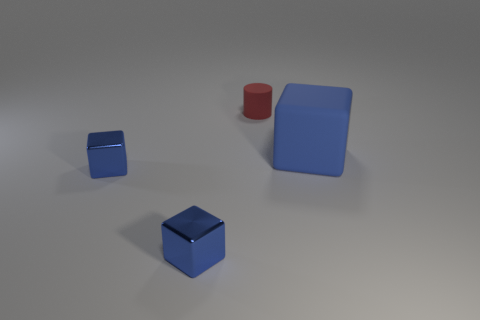Add 1 big cubes. How many objects exist? 5 Subtract all cylinders. How many objects are left? 3 Add 3 blue shiny things. How many blue shiny things are left? 5 Add 3 small metallic cubes. How many small metallic cubes exist? 5 Subtract 0 green cylinders. How many objects are left? 4 Subtract all big matte objects. Subtract all tiny red cylinders. How many objects are left? 2 